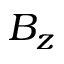Convert formula to latex. <formula><loc_0><loc_0><loc_500><loc_500>B _ { z }</formula> 